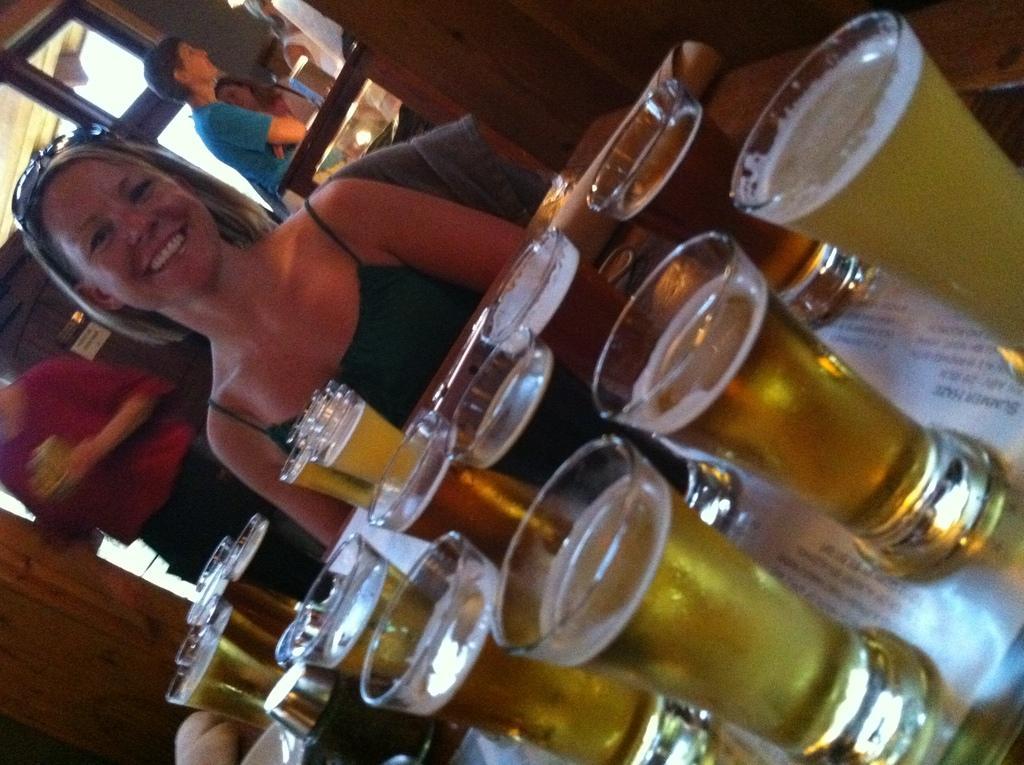In one or two sentences, can you explain what this image depicts? In this image, we can see glasses on the table which are filled with drink, and there is a lady sitting and smiling. In the background, there are some people standing. 